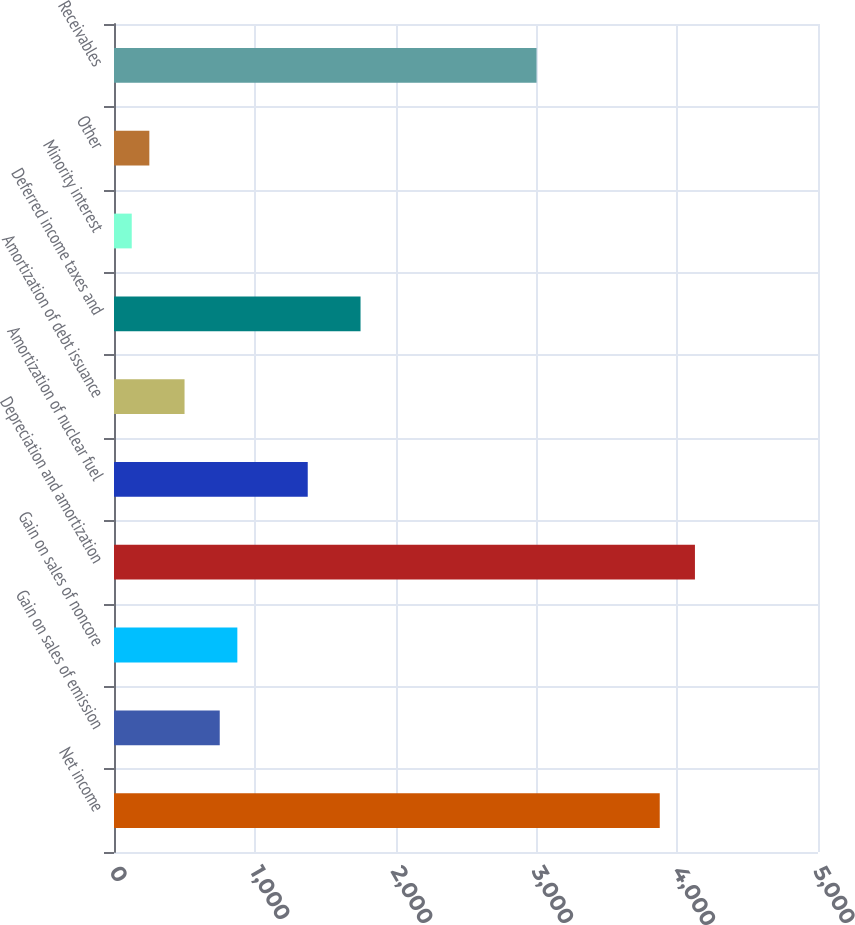Convert chart to OTSL. <chart><loc_0><loc_0><loc_500><loc_500><bar_chart><fcel>Net income<fcel>Gain on sales of emission<fcel>Gain on sales of noncore<fcel>Depreciation and amortization<fcel>Amortization of nuclear fuel<fcel>Amortization of debt issuance<fcel>Deferred income taxes and<fcel>Minority interest<fcel>Other<fcel>Receivables<nl><fcel>3876<fcel>751<fcel>876<fcel>4126<fcel>1376<fcel>501<fcel>1751<fcel>126<fcel>251<fcel>3001<nl></chart> 